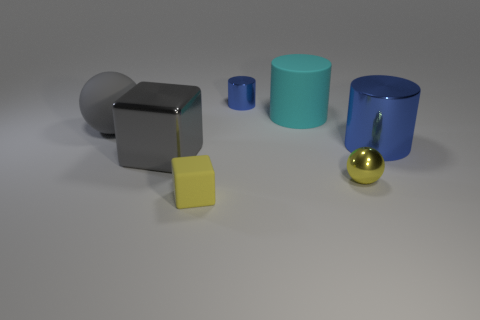What shape is the rubber thing that is the same color as the big cube?
Your answer should be very brief. Sphere. Is the material of the yellow thing right of the tiny blue metallic cylinder the same as the large sphere?
Provide a short and direct response. No. There is a yellow thing to the right of the large rubber thing that is behind the big gray matte object; what is its material?
Provide a short and direct response. Metal. How many other small things have the same shape as the cyan thing?
Your answer should be very brief. 1. There is a blue cylinder behind the big metal thing right of the tiny matte object in front of the big gray shiny block; what size is it?
Give a very brief answer. Small. How many yellow objects are either metal blocks or rubber spheres?
Your response must be concise. 0. There is a tiny blue shiny object left of the small yellow ball; is it the same shape as the big blue thing?
Keep it short and to the point. Yes. Are there more cyan objects that are in front of the big blue shiny thing than blue shiny cylinders?
Ensure brevity in your answer.  No. How many cyan objects are the same size as the cyan cylinder?
Keep it short and to the point. 0. The metal sphere that is the same color as the tiny cube is what size?
Make the answer very short. Small. 